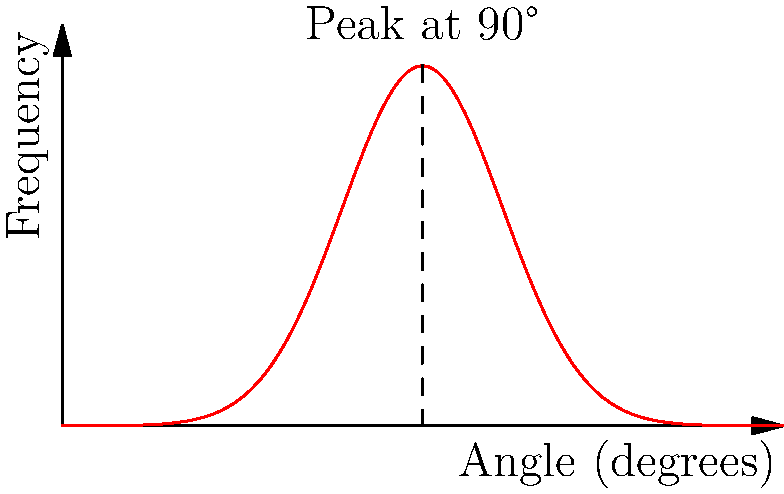In a tissue engineering scaffold, nanofibers show an angular distribution as depicted in the graph. What property of the scaffold does this distribution suggest, and how might it affect cell behavior? To answer this question, let's analyze the graph step-by-step:

1. The x-axis represents the angle of nanofibers from 0° to 180°.
2. The y-axis represents the frequency or abundance of nanofibers at each angle.
3. The distribution is bell-shaped and symmetrical, centered at 90°.
4. The peak at 90° indicates that most nanofibers are oriented perpendicular to a reference direction (0° or 180°).

This distribution suggests:

a) Isotropy in the plane perpendicular to the 90° direction: There's an equal likelihood of fibers oriented at angles on either side of 90°.

b) Anisotropy in the direction parallel to 90°: There's a strong preference for fibers to be oriented at or near 90°.

Effects on cell behavior:

1. Cell alignment: Cells tend to align along nanofibers. With this distribution, cells would likely orient themselves perpendicular to the reference direction.

2. Cell migration: The aligned fibers could create paths for directional cell migration, potentially guiding tissue formation.

3. Mechanical properties: The scaffold would have different mechanical properties in different directions (anisotropic), which can influence cell differentiation and tissue development.

4. Nutrient and waste diffusion: The alignment of fibers could create channels that affect the flow of nutrients and waste products, impacting cell viability and function.

5. Cell-scaffold interactions: The specific orientation of fibers could influence cell adhesion, spreading, and the formation of focal adhesions.

This type of scaffold design could be particularly useful for tissues with naturally aligned structures, such as muscle fibers or neural tissues.
Answer: Anisotropic scaffold with perpendicular fiber alignment, influencing cell orientation, migration, and tissue formation 